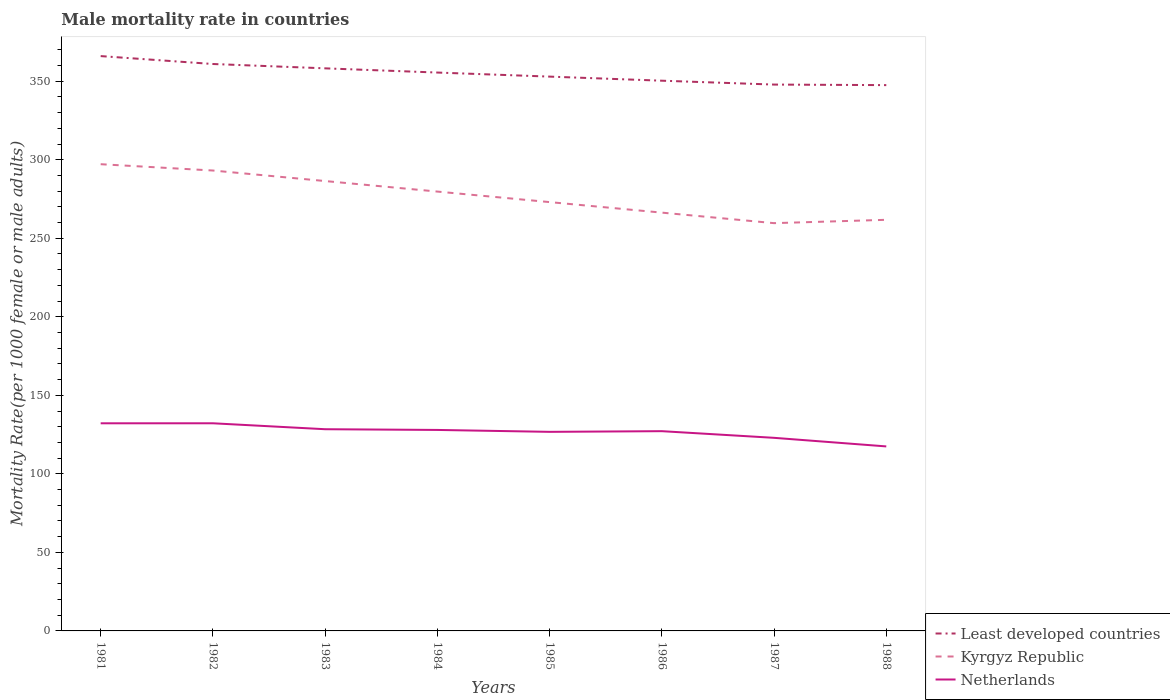Does the line corresponding to Least developed countries intersect with the line corresponding to Kyrgyz Republic?
Provide a succinct answer. No. Is the number of lines equal to the number of legend labels?
Your response must be concise. Yes. Across all years, what is the maximum male mortality rate in Least developed countries?
Your response must be concise. 347.52. In which year was the male mortality rate in Least developed countries maximum?
Provide a succinct answer. 1988. What is the total male mortality rate in Least developed countries in the graph?
Make the answer very short. 2.68. What is the difference between the highest and the second highest male mortality rate in Kyrgyz Republic?
Your answer should be very brief. 37.53. What is the difference between the highest and the lowest male mortality rate in Kyrgyz Republic?
Ensure brevity in your answer.  4. Is the male mortality rate in Kyrgyz Republic strictly greater than the male mortality rate in Least developed countries over the years?
Keep it short and to the point. Yes. How many years are there in the graph?
Ensure brevity in your answer.  8. Are the values on the major ticks of Y-axis written in scientific E-notation?
Your response must be concise. No. Does the graph contain any zero values?
Keep it short and to the point. No. How are the legend labels stacked?
Give a very brief answer. Vertical. What is the title of the graph?
Your answer should be compact. Male mortality rate in countries. What is the label or title of the X-axis?
Provide a short and direct response. Years. What is the label or title of the Y-axis?
Provide a short and direct response. Mortality Rate(per 1000 female or male adults). What is the Mortality Rate(per 1000 female or male adults) of Least developed countries in 1981?
Ensure brevity in your answer.  366.01. What is the Mortality Rate(per 1000 female or male adults) in Kyrgyz Republic in 1981?
Ensure brevity in your answer.  297.17. What is the Mortality Rate(per 1000 female or male adults) in Netherlands in 1981?
Keep it short and to the point. 132.2. What is the Mortality Rate(per 1000 female or male adults) of Least developed countries in 1982?
Provide a short and direct response. 360.97. What is the Mortality Rate(per 1000 female or male adults) of Kyrgyz Republic in 1982?
Your answer should be very brief. 293.15. What is the Mortality Rate(per 1000 female or male adults) of Netherlands in 1982?
Make the answer very short. 132.21. What is the Mortality Rate(per 1000 female or male adults) in Least developed countries in 1983?
Your answer should be compact. 358.21. What is the Mortality Rate(per 1000 female or male adults) of Kyrgyz Republic in 1983?
Give a very brief answer. 286.45. What is the Mortality Rate(per 1000 female or male adults) in Netherlands in 1983?
Make the answer very short. 128.43. What is the Mortality Rate(per 1000 female or male adults) in Least developed countries in 1984?
Provide a short and direct response. 355.53. What is the Mortality Rate(per 1000 female or male adults) of Kyrgyz Republic in 1984?
Your response must be concise. 279.75. What is the Mortality Rate(per 1000 female or male adults) of Netherlands in 1984?
Provide a short and direct response. 127.97. What is the Mortality Rate(per 1000 female or male adults) of Least developed countries in 1985?
Your answer should be very brief. 352.95. What is the Mortality Rate(per 1000 female or male adults) of Kyrgyz Republic in 1985?
Your response must be concise. 273.04. What is the Mortality Rate(per 1000 female or male adults) of Netherlands in 1985?
Offer a terse response. 126.75. What is the Mortality Rate(per 1000 female or male adults) of Least developed countries in 1986?
Ensure brevity in your answer.  350.34. What is the Mortality Rate(per 1000 female or male adults) in Kyrgyz Republic in 1986?
Provide a short and direct response. 266.34. What is the Mortality Rate(per 1000 female or male adults) of Netherlands in 1986?
Your answer should be very brief. 127.18. What is the Mortality Rate(per 1000 female or male adults) in Least developed countries in 1987?
Offer a very short reply. 347.87. What is the Mortality Rate(per 1000 female or male adults) in Kyrgyz Republic in 1987?
Provide a short and direct response. 259.64. What is the Mortality Rate(per 1000 female or male adults) in Netherlands in 1987?
Make the answer very short. 122.95. What is the Mortality Rate(per 1000 female or male adults) of Least developed countries in 1988?
Make the answer very short. 347.52. What is the Mortality Rate(per 1000 female or male adults) in Kyrgyz Republic in 1988?
Offer a terse response. 261.76. What is the Mortality Rate(per 1000 female or male adults) in Netherlands in 1988?
Offer a terse response. 117.48. Across all years, what is the maximum Mortality Rate(per 1000 female or male adults) of Least developed countries?
Provide a succinct answer. 366.01. Across all years, what is the maximum Mortality Rate(per 1000 female or male adults) in Kyrgyz Republic?
Your answer should be compact. 297.17. Across all years, what is the maximum Mortality Rate(per 1000 female or male adults) of Netherlands?
Give a very brief answer. 132.21. Across all years, what is the minimum Mortality Rate(per 1000 female or male adults) in Least developed countries?
Your response must be concise. 347.52. Across all years, what is the minimum Mortality Rate(per 1000 female or male adults) of Kyrgyz Republic?
Give a very brief answer. 259.64. Across all years, what is the minimum Mortality Rate(per 1000 female or male adults) in Netherlands?
Offer a terse response. 117.48. What is the total Mortality Rate(per 1000 female or male adults) in Least developed countries in the graph?
Keep it short and to the point. 2839.4. What is the total Mortality Rate(per 1000 female or male adults) in Kyrgyz Republic in the graph?
Keep it short and to the point. 2217.29. What is the total Mortality Rate(per 1000 female or male adults) of Netherlands in the graph?
Provide a short and direct response. 1015.17. What is the difference between the Mortality Rate(per 1000 female or male adults) in Least developed countries in 1981 and that in 1982?
Your answer should be compact. 5.04. What is the difference between the Mortality Rate(per 1000 female or male adults) in Kyrgyz Republic in 1981 and that in 1982?
Your response must be concise. 4.02. What is the difference between the Mortality Rate(per 1000 female or male adults) of Netherlands in 1981 and that in 1982?
Keep it short and to the point. -0.02. What is the difference between the Mortality Rate(per 1000 female or male adults) of Least developed countries in 1981 and that in 1983?
Keep it short and to the point. 7.8. What is the difference between the Mortality Rate(per 1000 female or male adults) in Kyrgyz Republic in 1981 and that in 1983?
Offer a very short reply. 10.72. What is the difference between the Mortality Rate(per 1000 female or male adults) of Netherlands in 1981 and that in 1983?
Your answer should be compact. 3.76. What is the difference between the Mortality Rate(per 1000 female or male adults) in Least developed countries in 1981 and that in 1984?
Your answer should be compact. 10.48. What is the difference between the Mortality Rate(per 1000 female or male adults) in Kyrgyz Republic in 1981 and that in 1984?
Give a very brief answer. 17.42. What is the difference between the Mortality Rate(per 1000 female or male adults) of Netherlands in 1981 and that in 1984?
Provide a succinct answer. 4.23. What is the difference between the Mortality Rate(per 1000 female or male adults) in Least developed countries in 1981 and that in 1985?
Provide a short and direct response. 13.06. What is the difference between the Mortality Rate(per 1000 female or male adults) of Kyrgyz Republic in 1981 and that in 1985?
Keep it short and to the point. 24.12. What is the difference between the Mortality Rate(per 1000 female or male adults) in Netherlands in 1981 and that in 1985?
Provide a succinct answer. 5.44. What is the difference between the Mortality Rate(per 1000 female or male adults) in Least developed countries in 1981 and that in 1986?
Your answer should be compact. 15.67. What is the difference between the Mortality Rate(per 1000 female or male adults) of Kyrgyz Republic in 1981 and that in 1986?
Your answer should be very brief. 30.83. What is the difference between the Mortality Rate(per 1000 female or male adults) of Netherlands in 1981 and that in 1986?
Provide a short and direct response. 5.01. What is the difference between the Mortality Rate(per 1000 female or male adults) in Least developed countries in 1981 and that in 1987?
Your answer should be compact. 18.13. What is the difference between the Mortality Rate(per 1000 female or male adults) of Kyrgyz Republic in 1981 and that in 1987?
Your response must be concise. 37.53. What is the difference between the Mortality Rate(per 1000 female or male adults) in Netherlands in 1981 and that in 1987?
Provide a short and direct response. 9.25. What is the difference between the Mortality Rate(per 1000 female or male adults) of Least developed countries in 1981 and that in 1988?
Make the answer very short. 18.49. What is the difference between the Mortality Rate(per 1000 female or male adults) of Kyrgyz Republic in 1981 and that in 1988?
Ensure brevity in your answer.  35.4. What is the difference between the Mortality Rate(per 1000 female or male adults) of Netherlands in 1981 and that in 1988?
Your answer should be compact. 14.71. What is the difference between the Mortality Rate(per 1000 female or male adults) in Least developed countries in 1982 and that in 1983?
Keep it short and to the point. 2.76. What is the difference between the Mortality Rate(per 1000 female or male adults) in Kyrgyz Republic in 1982 and that in 1983?
Your answer should be compact. 6.7. What is the difference between the Mortality Rate(per 1000 female or male adults) in Netherlands in 1982 and that in 1983?
Offer a very short reply. 3.78. What is the difference between the Mortality Rate(per 1000 female or male adults) of Least developed countries in 1982 and that in 1984?
Give a very brief answer. 5.44. What is the difference between the Mortality Rate(per 1000 female or male adults) of Kyrgyz Republic in 1982 and that in 1984?
Offer a very short reply. 13.4. What is the difference between the Mortality Rate(per 1000 female or male adults) in Netherlands in 1982 and that in 1984?
Keep it short and to the point. 4.24. What is the difference between the Mortality Rate(per 1000 female or male adults) of Least developed countries in 1982 and that in 1985?
Your answer should be very brief. 8.03. What is the difference between the Mortality Rate(per 1000 female or male adults) of Kyrgyz Republic in 1982 and that in 1985?
Offer a very short reply. 20.11. What is the difference between the Mortality Rate(per 1000 female or male adults) in Netherlands in 1982 and that in 1985?
Provide a succinct answer. 5.46. What is the difference between the Mortality Rate(per 1000 female or male adults) in Least developed countries in 1982 and that in 1986?
Offer a terse response. 10.63. What is the difference between the Mortality Rate(per 1000 female or male adults) of Kyrgyz Republic in 1982 and that in 1986?
Make the answer very short. 26.81. What is the difference between the Mortality Rate(per 1000 female or male adults) of Netherlands in 1982 and that in 1986?
Provide a short and direct response. 5.03. What is the difference between the Mortality Rate(per 1000 female or male adults) of Least developed countries in 1982 and that in 1987?
Your response must be concise. 13.1. What is the difference between the Mortality Rate(per 1000 female or male adults) of Kyrgyz Republic in 1982 and that in 1987?
Your answer should be compact. 33.51. What is the difference between the Mortality Rate(per 1000 female or male adults) in Netherlands in 1982 and that in 1987?
Ensure brevity in your answer.  9.27. What is the difference between the Mortality Rate(per 1000 female or male adults) in Least developed countries in 1982 and that in 1988?
Give a very brief answer. 13.45. What is the difference between the Mortality Rate(per 1000 female or male adults) in Kyrgyz Republic in 1982 and that in 1988?
Your answer should be very brief. 31.39. What is the difference between the Mortality Rate(per 1000 female or male adults) of Netherlands in 1982 and that in 1988?
Provide a succinct answer. 14.73. What is the difference between the Mortality Rate(per 1000 female or male adults) in Least developed countries in 1983 and that in 1984?
Make the answer very short. 2.68. What is the difference between the Mortality Rate(per 1000 female or male adults) of Kyrgyz Republic in 1983 and that in 1984?
Your response must be concise. 6.7. What is the difference between the Mortality Rate(per 1000 female or male adults) in Netherlands in 1983 and that in 1984?
Ensure brevity in your answer.  0.46. What is the difference between the Mortality Rate(per 1000 female or male adults) in Least developed countries in 1983 and that in 1985?
Provide a short and direct response. 5.26. What is the difference between the Mortality Rate(per 1000 female or male adults) of Kyrgyz Republic in 1983 and that in 1985?
Your answer should be compact. 13.4. What is the difference between the Mortality Rate(per 1000 female or male adults) of Netherlands in 1983 and that in 1985?
Provide a short and direct response. 1.68. What is the difference between the Mortality Rate(per 1000 female or male adults) in Least developed countries in 1983 and that in 1986?
Provide a succinct answer. 7.87. What is the difference between the Mortality Rate(per 1000 female or male adults) of Kyrgyz Republic in 1983 and that in 1986?
Make the answer very short. 20.11. What is the difference between the Mortality Rate(per 1000 female or male adults) of Netherlands in 1983 and that in 1986?
Keep it short and to the point. 1.25. What is the difference between the Mortality Rate(per 1000 female or male adults) in Least developed countries in 1983 and that in 1987?
Ensure brevity in your answer.  10.33. What is the difference between the Mortality Rate(per 1000 female or male adults) of Kyrgyz Republic in 1983 and that in 1987?
Your answer should be compact. 26.81. What is the difference between the Mortality Rate(per 1000 female or male adults) in Netherlands in 1983 and that in 1987?
Make the answer very short. 5.49. What is the difference between the Mortality Rate(per 1000 female or male adults) of Least developed countries in 1983 and that in 1988?
Ensure brevity in your answer.  10.69. What is the difference between the Mortality Rate(per 1000 female or male adults) of Kyrgyz Republic in 1983 and that in 1988?
Offer a terse response. 24.68. What is the difference between the Mortality Rate(per 1000 female or male adults) of Netherlands in 1983 and that in 1988?
Offer a very short reply. 10.95. What is the difference between the Mortality Rate(per 1000 female or male adults) of Least developed countries in 1984 and that in 1985?
Offer a terse response. 2.58. What is the difference between the Mortality Rate(per 1000 female or male adults) in Kyrgyz Republic in 1984 and that in 1985?
Give a very brief answer. 6.7. What is the difference between the Mortality Rate(per 1000 female or male adults) in Netherlands in 1984 and that in 1985?
Ensure brevity in your answer.  1.22. What is the difference between the Mortality Rate(per 1000 female or male adults) of Least developed countries in 1984 and that in 1986?
Provide a succinct answer. 5.19. What is the difference between the Mortality Rate(per 1000 female or male adults) in Kyrgyz Republic in 1984 and that in 1986?
Offer a very short reply. 13.4. What is the difference between the Mortality Rate(per 1000 female or male adults) in Netherlands in 1984 and that in 1986?
Provide a succinct answer. 0.79. What is the difference between the Mortality Rate(per 1000 female or male adults) in Least developed countries in 1984 and that in 1987?
Offer a terse response. 7.65. What is the difference between the Mortality Rate(per 1000 female or male adults) in Kyrgyz Republic in 1984 and that in 1987?
Ensure brevity in your answer.  20.11. What is the difference between the Mortality Rate(per 1000 female or male adults) in Netherlands in 1984 and that in 1987?
Make the answer very short. 5.02. What is the difference between the Mortality Rate(per 1000 female or male adults) of Least developed countries in 1984 and that in 1988?
Give a very brief answer. 8.01. What is the difference between the Mortality Rate(per 1000 female or male adults) of Kyrgyz Republic in 1984 and that in 1988?
Ensure brevity in your answer.  17.98. What is the difference between the Mortality Rate(per 1000 female or male adults) in Netherlands in 1984 and that in 1988?
Your response must be concise. 10.49. What is the difference between the Mortality Rate(per 1000 female or male adults) in Least developed countries in 1985 and that in 1986?
Offer a very short reply. 2.6. What is the difference between the Mortality Rate(per 1000 female or male adults) in Kyrgyz Republic in 1985 and that in 1986?
Provide a succinct answer. 6.7. What is the difference between the Mortality Rate(per 1000 female or male adults) in Netherlands in 1985 and that in 1986?
Your answer should be very brief. -0.43. What is the difference between the Mortality Rate(per 1000 female or male adults) of Least developed countries in 1985 and that in 1987?
Provide a succinct answer. 5.07. What is the difference between the Mortality Rate(per 1000 female or male adults) in Kyrgyz Republic in 1985 and that in 1987?
Offer a very short reply. 13.4. What is the difference between the Mortality Rate(per 1000 female or male adults) in Netherlands in 1985 and that in 1987?
Your answer should be very brief. 3.81. What is the difference between the Mortality Rate(per 1000 female or male adults) of Least developed countries in 1985 and that in 1988?
Your answer should be compact. 5.42. What is the difference between the Mortality Rate(per 1000 female or male adults) of Kyrgyz Republic in 1985 and that in 1988?
Offer a very short reply. 11.28. What is the difference between the Mortality Rate(per 1000 female or male adults) of Netherlands in 1985 and that in 1988?
Keep it short and to the point. 9.27. What is the difference between the Mortality Rate(per 1000 female or male adults) in Least developed countries in 1986 and that in 1987?
Your response must be concise. 2.47. What is the difference between the Mortality Rate(per 1000 female or male adults) of Kyrgyz Republic in 1986 and that in 1987?
Offer a terse response. 6.7. What is the difference between the Mortality Rate(per 1000 female or male adults) in Netherlands in 1986 and that in 1987?
Ensure brevity in your answer.  4.24. What is the difference between the Mortality Rate(per 1000 female or male adults) in Least developed countries in 1986 and that in 1988?
Ensure brevity in your answer.  2.82. What is the difference between the Mortality Rate(per 1000 female or male adults) in Kyrgyz Republic in 1986 and that in 1988?
Your response must be concise. 4.58. What is the difference between the Mortality Rate(per 1000 female or male adults) of Netherlands in 1986 and that in 1988?
Offer a terse response. 9.7. What is the difference between the Mortality Rate(per 1000 female or male adults) of Least developed countries in 1987 and that in 1988?
Keep it short and to the point. 0.35. What is the difference between the Mortality Rate(per 1000 female or male adults) of Kyrgyz Republic in 1987 and that in 1988?
Provide a succinct answer. -2.12. What is the difference between the Mortality Rate(per 1000 female or male adults) of Netherlands in 1987 and that in 1988?
Provide a succinct answer. 5.46. What is the difference between the Mortality Rate(per 1000 female or male adults) in Least developed countries in 1981 and the Mortality Rate(per 1000 female or male adults) in Kyrgyz Republic in 1982?
Give a very brief answer. 72.86. What is the difference between the Mortality Rate(per 1000 female or male adults) of Least developed countries in 1981 and the Mortality Rate(per 1000 female or male adults) of Netherlands in 1982?
Give a very brief answer. 233.8. What is the difference between the Mortality Rate(per 1000 female or male adults) of Kyrgyz Republic in 1981 and the Mortality Rate(per 1000 female or male adults) of Netherlands in 1982?
Offer a very short reply. 164.96. What is the difference between the Mortality Rate(per 1000 female or male adults) in Least developed countries in 1981 and the Mortality Rate(per 1000 female or male adults) in Kyrgyz Republic in 1983?
Keep it short and to the point. 79.56. What is the difference between the Mortality Rate(per 1000 female or male adults) in Least developed countries in 1981 and the Mortality Rate(per 1000 female or male adults) in Netherlands in 1983?
Offer a very short reply. 237.58. What is the difference between the Mortality Rate(per 1000 female or male adults) in Kyrgyz Republic in 1981 and the Mortality Rate(per 1000 female or male adults) in Netherlands in 1983?
Keep it short and to the point. 168.74. What is the difference between the Mortality Rate(per 1000 female or male adults) in Least developed countries in 1981 and the Mortality Rate(per 1000 female or male adults) in Kyrgyz Republic in 1984?
Provide a succinct answer. 86.26. What is the difference between the Mortality Rate(per 1000 female or male adults) of Least developed countries in 1981 and the Mortality Rate(per 1000 female or male adults) of Netherlands in 1984?
Make the answer very short. 238.04. What is the difference between the Mortality Rate(per 1000 female or male adults) of Kyrgyz Republic in 1981 and the Mortality Rate(per 1000 female or male adults) of Netherlands in 1984?
Give a very brief answer. 169.2. What is the difference between the Mortality Rate(per 1000 female or male adults) in Least developed countries in 1981 and the Mortality Rate(per 1000 female or male adults) in Kyrgyz Republic in 1985?
Provide a succinct answer. 92.97. What is the difference between the Mortality Rate(per 1000 female or male adults) of Least developed countries in 1981 and the Mortality Rate(per 1000 female or male adults) of Netherlands in 1985?
Your response must be concise. 239.26. What is the difference between the Mortality Rate(per 1000 female or male adults) of Kyrgyz Republic in 1981 and the Mortality Rate(per 1000 female or male adults) of Netherlands in 1985?
Offer a terse response. 170.41. What is the difference between the Mortality Rate(per 1000 female or male adults) in Least developed countries in 1981 and the Mortality Rate(per 1000 female or male adults) in Kyrgyz Republic in 1986?
Provide a short and direct response. 99.67. What is the difference between the Mortality Rate(per 1000 female or male adults) of Least developed countries in 1981 and the Mortality Rate(per 1000 female or male adults) of Netherlands in 1986?
Your response must be concise. 238.82. What is the difference between the Mortality Rate(per 1000 female or male adults) of Kyrgyz Republic in 1981 and the Mortality Rate(per 1000 female or male adults) of Netherlands in 1986?
Offer a very short reply. 169.98. What is the difference between the Mortality Rate(per 1000 female or male adults) in Least developed countries in 1981 and the Mortality Rate(per 1000 female or male adults) in Kyrgyz Republic in 1987?
Your answer should be compact. 106.37. What is the difference between the Mortality Rate(per 1000 female or male adults) of Least developed countries in 1981 and the Mortality Rate(per 1000 female or male adults) of Netherlands in 1987?
Your response must be concise. 243.06. What is the difference between the Mortality Rate(per 1000 female or male adults) in Kyrgyz Republic in 1981 and the Mortality Rate(per 1000 female or male adults) in Netherlands in 1987?
Your answer should be compact. 174.22. What is the difference between the Mortality Rate(per 1000 female or male adults) of Least developed countries in 1981 and the Mortality Rate(per 1000 female or male adults) of Kyrgyz Republic in 1988?
Provide a short and direct response. 104.25. What is the difference between the Mortality Rate(per 1000 female or male adults) in Least developed countries in 1981 and the Mortality Rate(per 1000 female or male adults) in Netherlands in 1988?
Keep it short and to the point. 248.53. What is the difference between the Mortality Rate(per 1000 female or male adults) of Kyrgyz Republic in 1981 and the Mortality Rate(per 1000 female or male adults) of Netherlands in 1988?
Offer a terse response. 179.69. What is the difference between the Mortality Rate(per 1000 female or male adults) in Least developed countries in 1982 and the Mortality Rate(per 1000 female or male adults) in Kyrgyz Republic in 1983?
Provide a succinct answer. 74.53. What is the difference between the Mortality Rate(per 1000 female or male adults) of Least developed countries in 1982 and the Mortality Rate(per 1000 female or male adults) of Netherlands in 1983?
Your answer should be very brief. 232.54. What is the difference between the Mortality Rate(per 1000 female or male adults) of Kyrgyz Republic in 1982 and the Mortality Rate(per 1000 female or male adults) of Netherlands in 1983?
Offer a very short reply. 164.72. What is the difference between the Mortality Rate(per 1000 female or male adults) of Least developed countries in 1982 and the Mortality Rate(per 1000 female or male adults) of Kyrgyz Republic in 1984?
Offer a very short reply. 81.23. What is the difference between the Mortality Rate(per 1000 female or male adults) of Least developed countries in 1982 and the Mortality Rate(per 1000 female or male adults) of Netherlands in 1984?
Provide a short and direct response. 233. What is the difference between the Mortality Rate(per 1000 female or male adults) of Kyrgyz Republic in 1982 and the Mortality Rate(per 1000 female or male adults) of Netherlands in 1984?
Provide a short and direct response. 165.18. What is the difference between the Mortality Rate(per 1000 female or male adults) in Least developed countries in 1982 and the Mortality Rate(per 1000 female or male adults) in Kyrgyz Republic in 1985?
Your answer should be compact. 87.93. What is the difference between the Mortality Rate(per 1000 female or male adults) of Least developed countries in 1982 and the Mortality Rate(per 1000 female or male adults) of Netherlands in 1985?
Give a very brief answer. 234.22. What is the difference between the Mortality Rate(per 1000 female or male adults) of Kyrgyz Republic in 1982 and the Mortality Rate(per 1000 female or male adults) of Netherlands in 1985?
Your response must be concise. 166.4. What is the difference between the Mortality Rate(per 1000 female or male adults) of Least developed countries in 1982 and the Mortality Rate(per 1000 female or male adults) of Kyrgyz Republic in 1986?
Ensure brevity in your answer.  94.63. What is the difference between the Mortality Rate(per 1000 female or male adults) in Least developed countries in 1982 and the Mortality Rate(per 1000 female or male adults) in Netherlands in 1986?
Offer a very short reply. 233.79. What is the difference between the Mortality Rate(per 1000 female or male adults) of Kyrgyz Republic in 1982 and the Mortality Rate(per 1000 female or male adults) of Netherlands in 1986?
Ensure brevity in your answer.  165.97. What is the difference between the Mortality Rate(per 1000 female or male adults) of Least developed countries in 1982 and the Mortality Rate(per 1000 female or male adults) of Kyrgyz Republic in 1987?
Your answer should be compact. 101.33. What is the difference between the Mortality Rate(per 1000 female or male adults) in Least developed countries in 1982 and the Mortality Rate(per 1000 female or male adults) in Netherlands in 1987?
Offer a terse response. 238.03. What is the difference between the Mortality Rate(per 1000 female or male adults) of Kyrgyz Republic in 1982 and the Mortality Rate(per 1000 female or male adults) of Netherlands in 1987?
Offer a terse response. 170.2. What is the difference between the Mortality Rate(per 1000 female or male adults) in Least developed countries in 1982 and the Mortality Rate(per 1000 female or male adults) in Kyrgyz Republic in 1988?
Provide a short and direct response. 99.21. What is the difference between the Mortality Rate(per 1000 female or male adults) of Least developed countries in 1982 and the Mortality Rate(per 1000 female or male adults) of Netherlands in 1988?
Provide a short and direct response. 243.49. What is the difference between the Mortality Rate(per 1000 female or male adults) of Kyrgyz Republic in 1982 and the Mortality Rate(per 1000 female or male adults) of Netherlands in 1988?
Make the answer very short. 175.67. What is the difference between the Mortality Rate(per 1000 female or male adults) in Least developed countries in 1983 and the Mortality Rate(per 1000 female or male adults) in Kyrgyz Republic in 1984?
Provide a short and direct response. 78.46. What is the difference between the Mortality Rate(per 1000 female or male adults) in Least developed countries in 1983 and the Mortality Rate(per 1000 female or male adults) in Netherlands in 1984?
Your answer should be very brief. 230.24. What is the difference between the Mortality Rate(per 1000 female or male adults) in Kyrgyz Republic in 1983 and the Mortality Rate(per 1000 female or male adults) in Netherlands in 1984?
Ensure brevity in your answer.  158.48. What is the difference between the Mortality Rate(per 1000 female or male adults) of Least developed countries in 1983 and the Mortality Rate(per 1000 female or male adults) of Kyrgyz Republic in 1985?
Offer a terse response. 85.17. What is the difference between the Mortality Rate(per 1000 female or male adults) of Least developed countries in 1983 and the Mortality Rate(per 1000 female or male adults) of Netherlands in 1985?
Keep it short and to the point. 231.46. What is the difference between the Mortality Rate(per 1000 female or male adults) of Kyrgyz Republic in 1983 and the Mortality Rate(per 1000 female or male adults) of Netherlands in 1985?
Your answer should be compact. 159.69. What is the difference between the Mortality Rate(per 1000 female or male adults) of Least developed countries in 1983 and the Mortality Rate(per 1000 female or male adults) of Kyrgyz Republic in 1986?
Ensure brevity in your answer.  91.87. What is the difference between the Mortality Rate(per 1000 female or male adults) of Least developed countries in 1983 and the Mortality Rate(per 1000 female or male adults) of Netherlands in 1986?
Provide a short and direct response. 231.03. What is the difference between the Mortality Rate(per 1000 female or male adults) of Kyrgyz Republic in 1983 and the Mortality Rate(per 1000 female or male adults) of Netherlands in 1986?
Offer a very short reply. 159.26. What is the difference between the Mortality Rate(per 1000 female or male adults) in Least developed countries in 1983 and the Mortality Rate(per 1000 female or male adults) in Kyrgyz Republic in 1987?
Your answer should be compact. 98.57. What is the difference between the Mortality Rate(per 1000 female or male adults) in Least developed countries in 1983 and the Mortality Rate(per 1000 female or male adults) in Netherlands in 1987?
Your answer should be very brief. 235.26. What is the difference between the Mortality Rate(per 1000 female or male adults) in Kyrgyz Republic in 1983 and the Mortality Rate(per 1000 female or male adults) in Netherlands in 1987?
Give a very brief answer. 163.5. What is the difference between the Mortality Rate(per 1000 female or male adults) of Least developed countries in 1983 and the Mortality Rate(per 1000 female or male adults) of Kyrgyz Republic in 1988?
Make the answer very short. 96.45. What is the difference between the Mortality Rate(per 1000 female or male adults) of Least developed countries in 1983 and the Mortality Rate(per 1000 female or male adults) of Netherlands in 1988?
Ensure brevity in your answer.  240.73. What is the difference between the Mortality Rate(per 1000 female or male adults) of Kyrgyz Republic in 1983 and the Mortality Rate(per 1000 female or male adults) of Netherlands in 1988?
Offer a terse response. 168.97. What is the difference between the Mortality Rate(per 1000 female or male adults) in Least developed countries in 1984 and the Mortality Rate(per 1000 female or male adults) in Kyrgyz Republic in 1985?
Give a very brief answer. 82.49. What is the difference between the Mortality Rate(per 1000 female or male adults) in Least developed countries in 1984 and the Mortality Rate(per 1000 female or male adults) in Netherlands in 1985?
Ensure brevity in your answer.  228.78. What is the difference between the Mortality Rate(per 1000 female or male adults) of Kyrgyz Republic in 1984 and the Mortality Rate(per 1000 female or male adults) of Netherlands in 1985?
Ensure brevity in your answer.  152.99. What is the difference between the Mortality Rate(per 1000 female or male adults) of Least developed countries in 1984 and the Mortality Rate(per 1000 female or male adults) of Kyrgyz Republic in 1986?
Provide a succinct answer. 89.19. What is the difference between the Mortality Rate(per 1000 female or male adults) in Least developed countries in 1984 and the Mortality Rate(per 1000 female or male adults) in Netherlands in 1986?
Offer a very short reply. 228.34. What is the difference between the Mortality Rate(per 1000 female or male adults) in Kyrgyz Republic in 1984 and the Mortality Rate(per 1000 female or male adults) in Netherlands in 1986?
Keep it short and to the point. 152.56. What is the difference between the Mortality Rate(per 1000 female or male adults) of Least developed countries in 1984 and the Mortality Rate(per 1000 female or male adults) of Kyrgyz Republic in 1987?
Ensure brevity in your answer.  95.89. What is the difference between the Mortality Rate(per 1000 female or male adults) of Least developed countries in 1984 and the Mortality Rate(per 1000 female or male adults) of Netherlands in 1987?
Provide a short and direct response. 232.58. What is the difference between the Mortality Rate(per 1000 female or male adults) of Kyrgyz Republic in 1984 and the Mortality Rate(per 1000 female or male adults) of Netherlands in 1987?
Your response must be concise. 156.8. What is the difference between the Mortality Rate(per 1000 female or male adults) of Least developed countries in 1984 and the Mortality Rate(per 1000 female or male adults) of Kyrgyz Republic in 1988?
Your answer should be compact. 93.77. What is the difference between the Mortality Rate(per 1000 female or male adults) of Least developed countries in 1984 and the Mortality Rate(per 1000 female or male adults) of Netherlands in 1988?
Ensure brevity in your answer.  238.05. What is the difference between the Mortality Rate(per 1000 female or male adults) in Kyrgyz Republic in 1984 and the Mortality Rate(per 1000 female or male adults) in Netherlands in 1988?
Offer a terse response. 162.26. What is the difference between the Mortality Rate(per 1000 female or male adults) in Least developed countries in 1985 and the Mortality Rate(per 1000 female or male adults) in Kyrgyz Republic in 1986?
Your answer should be very brief. 86.6. What is the difference between the Mortality Rate(per 1000 female or male adults) of Least developed countries in 1985 and the Mortality Rate(per 1000 female or male adults) of Netherlands in 1986?
Make the answer very short. 225.76. What is the difference between the Mortality Rate(per 1000 female or male adults) of Kyrgyz Republic in 1985 and the Mortality Rate(per 1000 female or male adults) of Netherlands in 1986?
Provide a succinct answer. 145.86. What is the difference between the Mortality Rate(per 1000 female or male adults) in Least developed countries in 1985 and the Mortality Rate(per 1000 female or male adults) in Kyrgyz Republic in 1987?
Provide a short and direct response. 93.31. What is the difference between the Mortality Rate(per 1000 female or male adults) of Least developed countries in 1985 and the Mortality Rate(per 1000 female or male adults) of Netherlands in 1987?
Provide a short and direct response. 230. What is the difference between the Mortality Rate(per 1000 female or male adults) in Kyrgyz Republic in 1985 and the Mortality Rate(per 1000 female or male adults) in Netherlands in 1987?
Provide a short and direct response. 150.1. What is the difference between the Mortality Rate(per 1000 female or male adults) of Least developed countries in 1985 and the Mortality Rate(per 1000 female or male adults) of Kyrgyz Republic in 1988?
Offer a very short reply. 91.18. What is the difference between the Mortality Rate(per 1000 female or male adults) of Least developed countries in 1985 and the Mortality Rate(per 1000 female or male adults) of Netherlands in 1988?
Make the answer very short. 235.46. What is the difference between the Mortality Rate(per 1000 female or male adults) in Kyrgyz Republic in 1985 and the Mortality Rate(per 1000 female or male adults) in Netherlands in 1988?
Offer a very short reply. 155.56. What is the difference between the Mortality Rate(per 1000 female or male adults) of Least developed countries in 1986 and the Mortality Rate(per 1000 female or male adults) of Kyrgyz Republic in 1987?
Your answer should be compact. 90.7. What is the difference between the Mortality Rate(per 1000 female or male adults) of Least developed countries in 1986 and the Mortality Rate(per 1000 female or male adults) of Netherlands in 1987?
Ensure brevity in your answer.  227.39. What is the difference between the Mortality Rate(per 1000 female or male adults) of Kyrgyz Republic in 1986 and the Mortality Rate(per 1000 female or male adults) of Netherlands in 1987?
Give a very brief answer. 143.39. What is the difference between the Mortality Rate(per 1000 female or male adults) of Least developed countries in 1986 and the Mortality Rate(per 1000 female or male adults) of Kyrgyz Republic in 1988?
Keep it short and to the point. 88.58. What is the difference between the Mortality Rate(per 1000 female or male adults) of Least developed countries in 1986 and the Mortality Rate(per 1000 female or male adults) of Netherlands in 1988?
Ensure brevity in your answer.  232.86. What is the difference between the Mortality Rate(per 1000 female or male adults) of Kyrgyz Republic in 1986 and the Mortality Rate(per 1000 female or male adults) of Netherlands in 1988?
Keep it short and to the point. 148.86. What is the difference between the Mortality Rate(per 1000 female or male adults) in Least developed countries in 1987 and the Mortality Rate(per 1000 female or male adults) in Kyrgyz Republic in 1988?
Provide a short and direct response. 86.11. What is the difference between the Mortality Rate(per 1000 female or male adults) of Least developed countries in 1987 and the Mortality Rate(per 1000 female or male adults) of Netherlands in 1988?
Provide a short and direct response. 230.39. What is the difference between the Mortality Rate(per 1000 female or male adults) in Kyrgyz Republic in 1987 and the Mortality Rate(per 1000 female or male adults) in Netherlands in 1988?
Provide a short and direct response. 142.16. What is the average Mortality Rate(per 1000 female or male adults) in Least developed countries per year?
Offer a very short reply. 354.93. What is the average Mortality Rate(per 1000 female or male adults) in Kyrgyz Republic per year?
Offer a terse response. 277.16. What is the average Mortality Rate(per 1000 female or male adults) of Netherlands per year?
Your response must be concise. 126.9. In the year 1981, what is the difference between the Mortality Rate(per 1000 female or male adults) in Least developed countries and Mortality Rate(per 1000 female or male adults) in Kyrgyz Republic?
Your response must be concise. 68.84. In the year 1981, what is the difference between the Mortality Rate(per 1000 female or male adults) in Least developed countries and Mortality Rate(per 1000 female or male adults) in Netherlands?
Ensure brevity in your answer.  233.81. In the year 1981, what is the difference between the Mortality Rate(per 1000 female or male adults) of Kyrgyz Republic and Mortality Rate(per 1000 female or male adults) of Netherlands?
Your answer should be compact. 164.97. In the year 1982, what is the difference between the Mortality Rate(per 1000 female or male adults) of Least developed countries and Mortality Rate(per 1000 female or male adults) of Kyrgyz Republic?
Provide a short and direct response. 67.82. In the year 1982, what is the difference between the Mortality Rate(per 1000 female or male adults) in Least developed countries and Mortality Rate(per 1000 female or male adults) in Netherlands?
Provide a short and direct response. 228.76. In the year 1982, what is the difference between the Mortality Rate(per 1000 female or male adults) in Kyrgyz Republic and Mortality Rate(per 1000 female or male adults) in Netherlands?
Offer a terse response. 160.94. In the year 1983, what is the difference between the Mortality Rate(per 1000 female or male adults) in Least developed countries and Mortality Rate(per 1000 female or male adults) in Kyrgyz Republic?
Make the answer very short. 71.76. In the year 1983, what is the difference between the Mortality Rate(per 1000 female or male adults) of Least developed countries and Mortality Rate(per 1000 female or male adults) of Netherlands?
Keep it short and to the point. 229.78. In the year 1983, what is the difference between the Mortality Rate(per 1000 female or male adults) in Kyrgyz Republic and Mortality Rate(per 1000 female or male adults) in Netherlands?
Provide a short and direct response. 158.01. In the year 1984, what is the difference between the Mortality Rate(per 1000 female or male adults) in Least developed countries and Mortality Rate(per 1000 female or male adults) in Kyrgyz Republic?
Your response must be concise. 75.78. In the year 1984, what is the difference between the Mortality Rate(per 1000 female or male adults) of Least developed countries and Mortality Rate(per 1000 female or male adults) of Netherlands?
Offer a terse response. 227.56. In the year 1984, what is the difference between the Mortality Rate(per 1000 female or male adults) in Kyrgyz Republic and Mortality Rate(per 1000 female or male adults) in Netherlands?
Make the answer very short. 151.78. In the year 1985, what is the difference between the Mortality Rate(per 1000 female or male adults) in Least developed countries and Mortality Rate(per 1000 female or male adults) in Kyrgyz Republic?
Offer a terse response. 79.9. In the year 1985, what is the difference between the Mortality Rate(per 1000 female or male adults) of Least developed countries and Mortality Rate(per 1000 female or male adults) of Netherlands?
Your answer should be very brief. 226.19. In the year 1985, what is the difference between the Mortality Rate(per 1000 female or male adults) in Kyrgyz Republic and Mortality Rate(per 1000 female or male adults) in Netherlands?
Make the answer very short. 146.29. In the year 1986, what is the difference between the Mortality Rate(per 1000 female or male adults) of Least developed countries and Mortality Rate(per 1000 female or male adults) of Kyrgyz Republic?
Your answer should be compact. 84. In the year 1986, what is the difference between the Mortality Rate(per 1000 female or male adults) of Least developed countries and Mortality Rate(per 1000 female or male adults) of Netherlands?
Provide a short and direct response. 223.16. In the year 1986, what is the difference between the Mortality Rate(per 1000 female or male adults) of Kyrgyz Republic and Mortality Rate(per 1000 female or male adults) of Netherlands?
Provide a short and direct response. 139.16. In the year 1987, what is the difference between the Mortality Rate(per 1000 female or male adults) in Least developed countries and Mortality Rate(per 1000 female or male adults) in Kyrgyz Republic?
Your answer should be very brief. 88.24. In the year 1987, what is the difference between the Mortality Rate(per 1000 female or male adults) of Least developed countries and Mortality Rate(per 1000 female or male adults) of Netherlands?
Provide a short and direct response. 224.93. In the year 1987, what is the difference between the Mortality Rate(per 1000 female or male adults) in Kyrgyz Republic and Mortality Rate(per 1000 female or male adults) in Netherlands?
Offer a terse response. 136.69. In the year 1988, what is the difference between the Mortality Rate(per 1000 female or male adults) of Least developed countries and Mortality Rate(per 1000 female or male adults) of Kyrgyz Republic?
Provide a short and direct response. 85.76. In the year 1988, what is the difference between the Mortality Rate(per 1000 female or male adults) in Least developed countries and Mortality Rate(per 1000 female or male adults) in Netherlands?
Keep it short and to the point. 230.04. In the year 1988, what is the difference between the Mortality Rate(per 1000 female or male adults) of Kyrgyz Republic and Mortality Rate(per 1000 female or male adults) of Netherlands?
Make the answer very short. 144.28. What is the ratio of the Mortality Rate(per 1000 female or male adults) in Least developed countries in 1981 to that in 1982?
Make the answer very short. 1.01. What is the ratio of the Mortality Rate(per 1000 female or male adults) of Kyrgyz Republic in 1981 to that in 1982?
Your answer should be very brief. 1.01. What is the ratio of the Mortality Rate(per 1000 female or male adults) of Least developed countries in 1981 to that in 1983?
Your answer should be compact. 1.02. What is the ratio of the Mortality Rate(per 1000 female or male adults) in Kyrgyz Republic in 1981 to that in 1983?
Ensure brevity in your answer.  1.04. What is the ratio of the Mortality Rate(per 1000 female or male adults) of Netherlands in 1981 to that in 1983?
Make the answer very short. 1.03. What is the ratio of the Mortality Rate(per 1000 female or male adults) of Least developed countries in 1981 to that in 1984?
Your response must be concise. 1.03. What is the ratio of the Mortality Rate(per 1000 female or male adults) in Kyrgyz Republic in 1981 to that in 1984?
Offer a very short reply. 1.06. What is the ratio of the Mortality Rate(per 1000 female or male adults) of Netherlands in 1981 to that in 1984?
Offer a terse response. 1.03. What is the ratio of the Mortality Rate(per 1000 female or male adults) of Kyrgyz Republic in 1981 to that in 1985?
Make the answer very short. 1.09. What is the ratio of the Mortality Rate(per 1000 female or male adults) of Netherlands in 1981 to that in 1985?
Make the answer very short. 1.04. What is the ratio of the Mortality Rate(per 1000 female or male adults) in Least developed countries in 1981 to that in 1986?
Provide a succinct answer. 1.04. What is the ratio of the Mortality Rate(per 1000 female or male adults) in Kyrgyz Republic in 1981 to that in 1986?
Provide a short and direct response. 1.12. What is the ratio of the Mortality Rate(per 1000 female or male adults) of Netherlands in 1981 to that in 1986?
Ensure brevity in your answer.  1.04. What is the ratio of the Mortality Rate(per 1000 female or male adults) in Least developed countries in 1981 to that in 1987?
Provide a succinct answer. 1.05. What is the ratio of the Mortality Rate(per 1000 female or male adults) in Kyrgyz Republic in 1981 to that in 1987?
Offer a very short reply. 1.14. What is the ratio of the Mortality Rate(per 1000 female or male adults) of Netherlands in 1981 to that in 1987?
Keep it short and to the point. 1.08. What is the ratio of the Mortality Rate(per 1000 female or male adults) of Least developed countries in 1981 to that in 1988?
Ensure brevity in your answer.  1.05. What is the ratio of the Mortality Rate(per 1000 female or male adults) in Kyrgyz Republic in 1981 to that in 1988?
Your response must be concise. 1.14. What is the ratio of the Mortality Rate(per 1000 female or male adults) of Netherlands in 1981 to that in 1988?
Keep it short and to the point. 1.13. What is the ratio of the Mortality Rate(per 1000 female or male adults) in Least developed countries in 1982 to that in 1983?
Your answer should be very brief. 1.01. What is the ratio of the Mortality Rate(per 1000 female or male adults) of Kyrgyz Republic in 1982 to that in 1983?
Make the answer very short. 1.02. What is the ratio of the Mortality Rate(per 1000 female or male adults) in Netherlands in 1982 to that in 1983?
Offer a very short reply. 1.03. What is the ratio of the Mortality Rate(per 1000 female or male adults) in Least developed countries in 1982 to that in 1984?
Offer a very short reply. 1.02. What is the ratio of the Mortality Rate(per 1000 female or male adults) of Kyrgyz Republic in 1982 to that in 1984?
Keep it short and to the point. 1.05. What is the ratio of the Mortality Rate(per 1000 female or male adults) in Netherlands in 1982 to that in 1984?
Give a very brief answer. 1.03. What is the ratio of the Mortality Rate(per 1000 female or male adults) of Least developed countries in 1982 to that in 1985?
Ensure brevity in your answer.  1.02. What is the ratio of the Mortality Rate(per 1000 female or male adults) of Kyrgyz Republic in 1982 to that in 1985?
Give a very brief answer. 1.07. What is the ratio of the Mortality Rate(per 1000 female or male adults) of Netherlands in 1982 to that in 1985?
Offer a very short reply. 1.04. What is the ratio of the Mortality Rate(per 1000 female or male adults) in Least developed countries in 1982 to that in 1986?
Give a very brief answer. 1.03. What is the ratio of the Mortality Rate(per 1000 female or male adults) of Kyrgyz Republic in 1982 to that in 1986?
Your answer should be compact. 1.1. What is the ratio of the Mortality Rate(per 1000 female or male adults) in Netherlands in 1982 to that in 1986?
Offer a terse response. 1.04. What is the ratio of the Mortality Rate(per 1000 female or male adults) of Least developed countries in 1982 to that in 1987?
Ensure brevity in your answer.  1.04. What is the ratio of the Mortality Rate(per 1000 female or male adults) in Kyrgyz Republic in 1982 to that in 1987?
Provide a succinct answer. 1.13. What is the ratio of the Mortality Rate(per 1000 female or male adults) in Netherlands in 1982 to that in 1987?
Keep it short and to the point. 1.08. What is the ratio of the Mortality Rate(per 1000 female or male adults) of Least developed countries in 1982 to that in 1988?
Your answer should be compact. 1.04. What is the ratio of the Mortality Rate(per 1000 female or male adults) in Kyrgyz Republic in 1982 to that in 1988?
Make the answer very short. 1.12. What is the ratio of the Mortality Rate(per 1000 female or male adults) of Netherlands in 1982 to that in 1988?
Offer a terse response. 1.13. What is the ratio of the Mortality Rate(per 1000 female or male adults) in Least developed countries in 1983 to that in 1984?
Your answer should be very brief. 1.01. What is the ratio of the Mortality Rate(per 1000 female or male adults) in Kyrgyz Republic in 1983 to that in 1984?
Provide a succinct answer. 1.02. What is the ratio of the Mortality Rate(per 1000 female or male adults) of Least developed countries in 1983 to that in 1985?
Provide a succinct answer. 1.01. What is the ratio of the Mortality Rate(per 1000 female or male adults) of Kyrgyz Republic in 1983 to that in 1985?
Ensure brevity in your answer.  1.05. What is the ratio of the Mortality Rate(per 1000 female or male adults) in Netherlands in 1983 to that in 1985?
Offer a very short reply. 1.01. What is the ratio of the Mortality Rate(per 1000 female or male adults) in Least developed countries in 1983 to that in 1986?
Give a very brief answer. 1.02. What is the ratio of the Mortality Rate(per 1000 female or male adults) of Kyrgyz Republic in 1983 to that in 1986?
Provide a succinct answer. 1.08. What is the ratio of the Mortality Rate(per 1000 female or male adults) of Netherlands in 1983 to that in 1986?
Offer a very short reply. 1.01. What is the ratio of the Mortality Rate(per 1000 female or male adults) in Least developed countries in 1983 to that in 1987?
Ensure brevity in your answer.  1.03. What is the ratio of the Mortality Rate(per 1000 female or male adults) in Kyrgyz Republic in 1983 to that in 1987?
Provide a short and direct response. 1.1. What is the ratio of the Mortality Rate(per 1000 female or male adults) in Netherlands in 1983 to that in 1987?
Your answer should be compact. 1.04. What is the ratio of the Mortality Rate(per 1000 female or male adults) in Least developed countries in 1983 to that in 1988?
Give a very brief answer. 1.03. What is the ratio of the Mortality Rate(per 1000 female or male adults) in Kyrgyz Republic in 1983 to that in 1988?
Provide a short and direct response. 1.09. What is the ratio of the Mortality Rate(per 1000 female or male adults) of Netherlands in 1983 to that in 1988?
Offer a very short reply. 1.09. What is the ratio of the Mortality Rate(per 1000 female or male adults) of Least developed countries in 1984 to that in 1985?
Your answer should be compact. 1.01. What is the ratio of the Mortality Rate(per 1000 female or male adults) of Kyrgyz Republic in 1984 to that in 1985?
Provide a succinct answer. 1.02. What is the ratio of the Mortality Rate(per 1000 female or male adults) of Netherlands in 1984 to that in 1985?
Provide a succinct answer. 1.01. What is the ratio of the Mortality Rate(per 1000 female or male adults) in Least developed countries in 1984 to that in 1986?
Ensure brevity in your answer.  1.01. What is the ratio of the Mortality Rate(per 1000 female or male adults) in Kyrgyz Republic in 1984 to that in 1986?
Offer a terse response. 1.05. What is the ratio of the Mortality Rate(per 1000 female or male adults) in Netherlands in 1984 to that in 1986?
Provide a short and direct response. 1.01. What is the ratio of the Mortality Rate(per 1000 female or male adults) of Kyrgyz Republic in 1984 to that in 1987?
Offer a very short reply. 1.08. What is the ratio of the Mortality Rate(per 1000 female or male adults) of Netherlands in 1984 to that in 1987?
Your answer should be compact. 1.04. What is the ratio of the Mortality Rate(per 1000 female or male adults) in Least developed countries in 1984 to that in 1988?
Offer a terse response. 1.02. What is the ratio of the Mortality Rate(per 1000 female or male adults) in Kyrgyz Republic in 1984 to that in 1988?
Your response must be concise. 1.07. What is the ratio of the Mortality Rate(per 1000 female or male adults) in Netherlands in 1984 to that in 1988?
Provide a succinct answer. 1.09. What is the ratio of the Mortality Rate(per 1000 female or male adults) of Least developed countries in 1985 to that in 1986?
Offer a terse response. 1.01. What is the ratio of the Mortality Rate(per 1000 female or male adults) in Kyrgyz Republic in 1985 to that in 1986?
Offer a very short reply. 1.03. What is the ratio of the Mortality Rate(per 1000 female or male adults) in Least developed countries in 1985 to that in 1987?
Provide a short and direct response. 1.01. What is the ratio of the Mortality Rate(per 1000 female or male adults) of Kyrgyz Republic in 1985 to that in 1987?
Keep it short and to the point. 1.05. What is the ratio of the Mortality Rate(per 1000 female or male adults) of Netherlands in 1985 to that in 1987?
Offer a terse response. 1.03. What is the ratio of the Mortality Rate(per 1000 female or male adults) in Least developed countries in 1985 to that in 1988?
Keep it short and to the point. 1.02. What is the ratio of the Mortality Rate(per 1000 female or male adults) of Kyrgyz Republic in 1985 to that in 1988?
Ensure brevity in your answer.  1.04. What is the ratio of the Mortality Rate(per 1000 female or male adults) in Netherlands in 1985 to that in 1988?
Offer a very short reply. 1.08. What is the ratio of the Mortality Rate(per 1000 female or male adults) of Least developed countries in 1986 to that in 1987?
Make the answer very short. 1.01. What is the ratio of the Mortality Rate(per 1000 female or male adults) in Kyrgyz Republic in 1986 to that in 1987?
Your response must be concise. 1.03. What is the ratio of the Mortality Rate(per 1000 female or male adults) in Netherlands in 1986 to that in 1987?
Offer a very short reply. 1.03. What is the ratio of the Mortality Rate(per 1000 female or male adults) of Least developed countries in 1986 to that in 1988?
Your answer should be compact. 1.01. What is the ratio of the Mortality Rate(per 1000 female or male adults) of Kyrgyz Republic in 1986 to that in 1988?
Your answer should be compact. 1.02. What is the ratio of the Mortality Rate(per 1000 female or male adults) of Netherlands in 1986 to that in 1988?
Make the answer very short. 1.08. What is the ratio of the Mortality Rate(per 1000 female or male adults) in Netherlands in 1987 to that in 1988?
Make the answer very short. 1.05. What is the difference between the highest and the second highest Mortality Rate(per 1000 female or male adults) of Least developed countries?
Provide a succinct answer. 5.04. What is the difference between the highest and the second highest Mortality Rate(per 1000 female or male adults) in Kyrgyz Republic?
Your answer should be very brief. 4.02. What is the difference between the highest and the second highest Mortality Rate(per 1000 female or male adults) of Netherlands?
Your answer should be very brief. 0.02. What is the difference between the highest and the lowest Mortality Rate(per 1000 female or male adults) in Least developed countries?
Provide a short and direct response. 18.49. What is the difference between the highest and the lowest Mortality Rate(per 1000 female or male adults) in Kyrgyz Republic?
Make the answer very short. 37.53. What is the difference between the highest and the lowest Mortality Rate(per 1000 female or male adults) in Netherlands?
Offer a terse response. 14.73. 